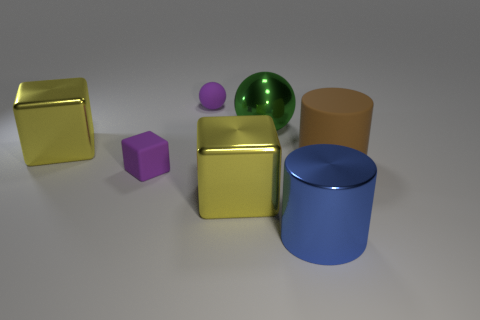There is another large object that is the same shape as the big blue metal object; what material is it?
Provide a succinct answer. Rubber. Is there any other thing that has the same material as the blue cylinder?
Ensure brevity in your answer.  Yes. What number of other objects are there of the same shape as the large green metal object?
Provide a short and direct response. 1. What number of green things are behind the large cube that is in front of the large object on the right side of the big blue shiny thing?
Make the answer very short. 1. What number of matte things are the same shape as the big blue metal thing?
Ensure brevity in your answer.  1. Does the big metallic thing that is left of the tiny ball have the same color as the tiny cube?
Give a very brief answer. No. What shape is the large thing that is behind the metal object that is on the left side of the tiny purple thing that is behind the purple rubber block?
Your response must be concise. Sphere. There is a green thing; is its size the same as the rubber object that is to the right of the big metal cylinder?
Give a very brief answer. Yes. Is there a ball that has the same size as the purple matte cube?
Your answer should be compact. Yes. How many other objects are there of the same material as the big brown cylinder?
Keep it short and to the point. 2. 